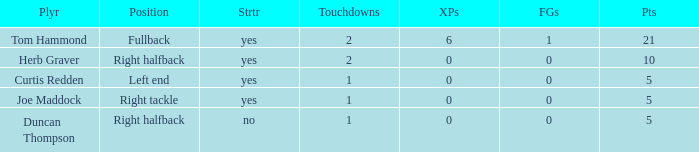Name the number of points for field goals being 1 1.0. 